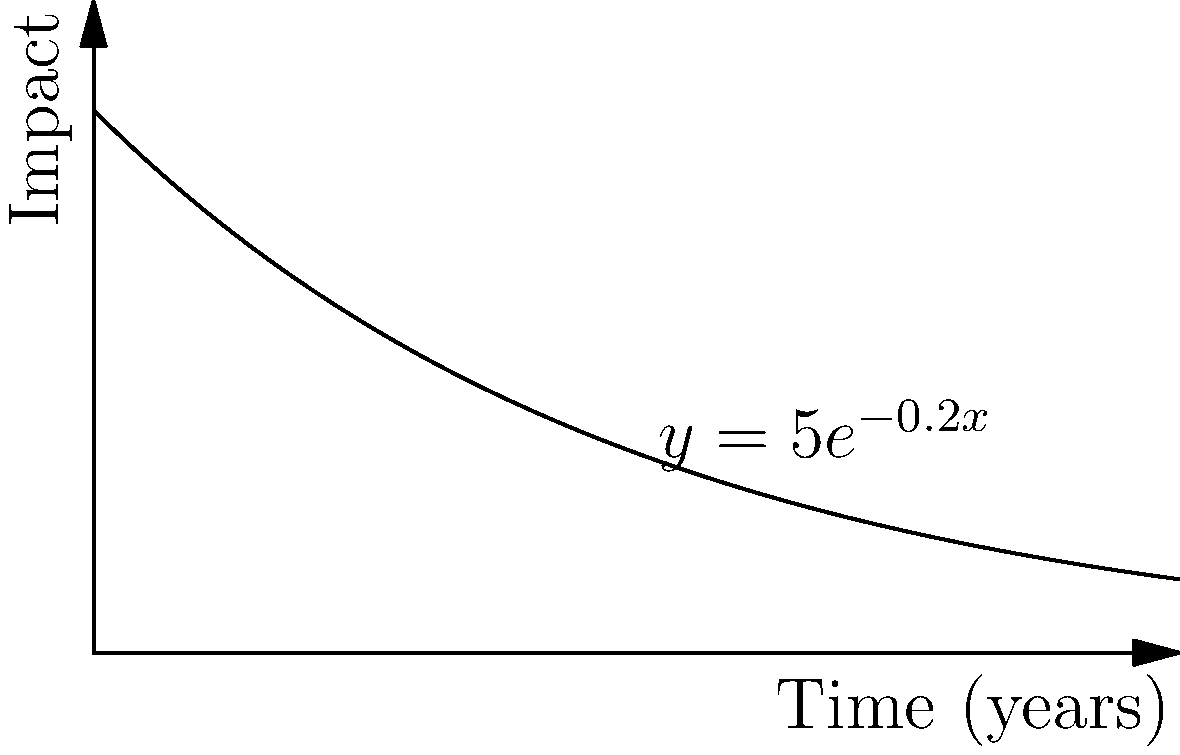A cultural exchange program's impact over time is modeled by the function $f(t) = 5e^{-0.2t}$, where $t$ is time in years and $f(t)$ represents the program's impact score. Calculate the total impact of the program over the first 10 years by finding the area under the curve from $t=0$ to $t=10$. To find the total impact, we need to integrate the function $f(t) = 5e^{-0.2t}$ from 0 to 10:

1) Set up the definite integral:
   $$\int_0^{10} 5e^{-0.2t} dt$$

2) To integrate, we use the rule $\int e^{ax} dx = \frac{1}{a}e^{ax} + C$:
   $$5 \int_0^{10} e^{-0.2t} dt = 5 \cdot \frac{1}{-0.2}e^{-0.2t}\bigg|_0^{10}$$

3) Evaluate the antiderivative at the limits:
   $$= -25e^{-0.2t}\bigg|_0^{10} = -25(e^{-2} - e^0)$$

4) Simplify:
   $$= -25(0.1353 - 1) = -25(-0.8647) = 21.6175$$

Therefore, the total impact over 10 years is approximately 21.62 impact-years.
Answer: 21.62 impact-years 